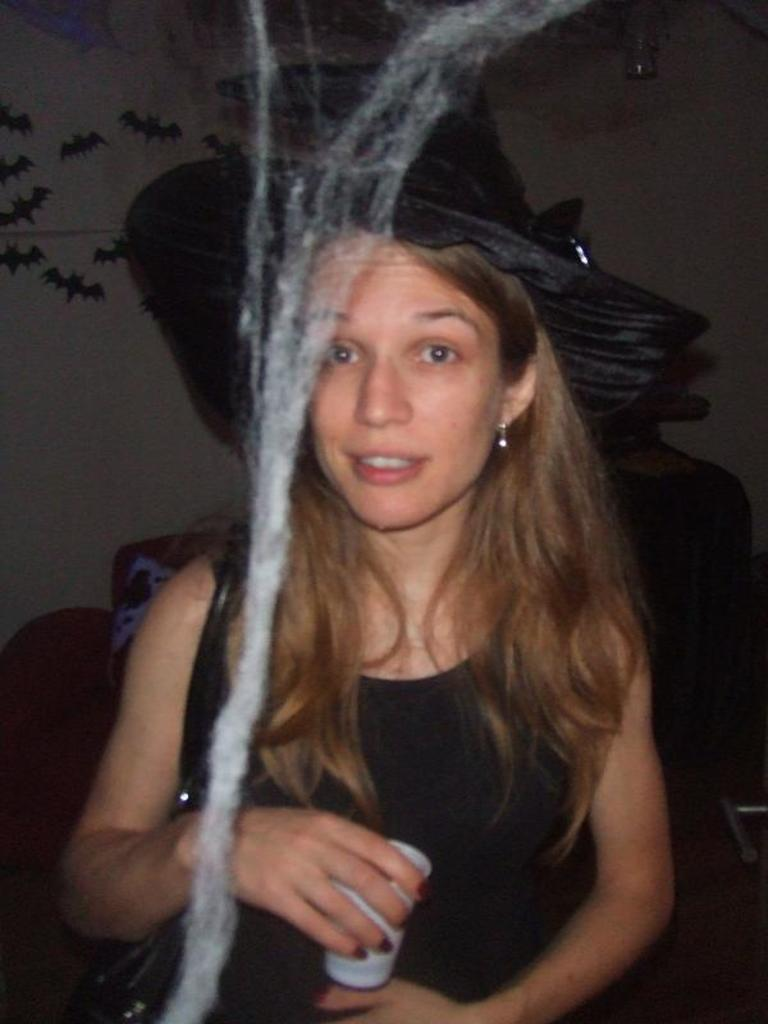What is the woman in the image wearing? The woman is wearing a black dress. What is the woman holding in the image? The woman is holding a cup. Can you describe the person behind the woman? There is another person behind the woman, but their appearance is not specified. What can be seen on the wall in the image? There are stickers visible on the wall. What is present in front of the woman? Cotton is present in front of the woman. What type of comb can be seen in the woman's hair in the image? There is no comb visible in the woman's hair in the image. 